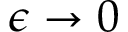<formula> <loc_0><loc_0><loc_500><loc_500>\epsilon \rightarrow 0</formula> 